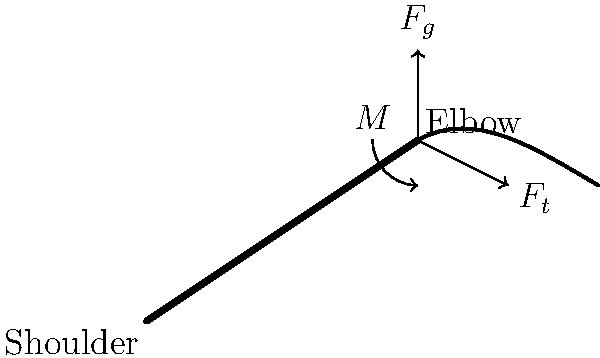A fisherman is casting a net in the Rupsha River. The weight of the net ($F_g$) is 50 N, and the tension in the fisherman's arm ($F_t$) is 80 N. If the length of the fisherman's forearm is 0.3 m, calculate the moment ($M$) about the elbow joint required to hold the net in the position shown. To solve this problem, we'll follow these steps:

1) First, we need to identify the forces acting on the fisherman's forearm:
   - The weight of the net ($F_g$) acting downward
   - The tension in the arm ($F_t$) acting at an angle

2) We'll assume the angle between the forearm and the tension force is approximately 30°.

3) To calculate the moment, we need to find the perpendicular distance from each force to the pivot point (elbow).

4) For $F_g$:
   - The perpendicular distance is the length of the forearm = 0.3 m

5) For $F_t$:
   - The perpendicular distance = $0.3 \cdot \sin(30°) = 0.15$ m

6) The moment is calculated using the formula: $M = F \cdot d$, where $F$ is the force and $d$ is the perpendicular distance.

7) Moment due to $F_g$: $M_g = 50 \text{ N} \cdot 0.3 \text{ m} = 15 \text{ N}\cdot\text{m}$ (clockwise)

8) Moment due to $F_t$: $M_t = 80 \text{ N} \cdot 0.15 \text{ m} = 12 \text{ N}\cdot\text{m}$ (counterclockwise)

9) The net moment required to hold the arm in equilibrium is:
   $M = M_g - M_t = 15 \text{ N}\cdot\text{m} - 12 \text{ N}\cdot\text{m} = 3 \text{ N}\cdot\text{m}$ (clockwise)

Therefore, a clockwise moment of 3 N⋅m is required at the elbow to hold the net in the given position.
Answer: 3 N⋅m clockwise 